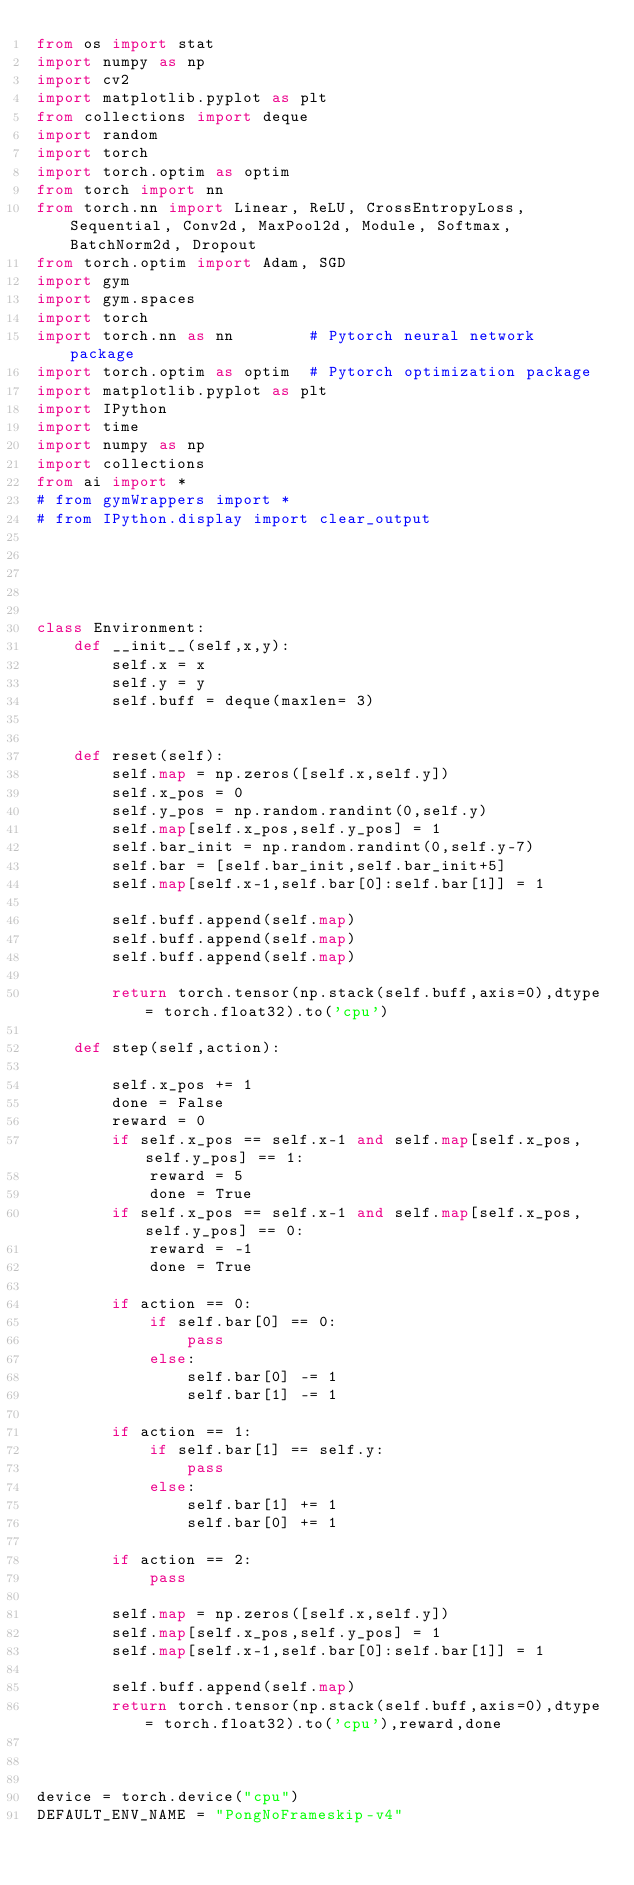Convert code to text. <code><loc_0><loc_0><loc_500><loc_500><_Python_>from os import stat
import numpy as np
import cv2
import matplotlib.pyplot as plt
from collections import deque
import random
import torch
import torch.optim as optim 
from torch import nn
from torch.nn import Linear, ReLU, CrossEntropyLoss, Sequential, Conv2d, MaxPool2d, Module, Softmax, BatchNorm2d, Dropout
from torch.optim import Adam, SGD
import gym
import gym.spaces
import torch
import torch.nn as nn        # Pytorch neural network package
import torch.optim as optim  # Pytorch optimization package
import matplotlib.pyplot as plt
import IPython
import time
import numpy as np
import collections
from ai import *
# from gymWrappers import *
# from IPython.display import clear_output





class Environment:
    def __init__(self,x,y):
        self.x = x
        self.y = y
        self.buff = deque(maxlen= 3)

        
    def reset(self):
        self.map = np.zeros([self.x,self.y])
        self.x_pos = 0
        self.y_pos = np.random.randint(0,self.y)
        self.map[self.x_pos,self.y_pos] = 1
        self.bar_init = np.random.randint(0,self.y-7)
        self.bar = [self.bar_init,self.bar_init+5]
        self.map[self.x-1,self.bar[0]:self.bar[1]] = 1

        self.buff.append(self.map)
        self.buff.append(self.map)
        self.buff.append(self.map)

        return torch.tensor(np.stack(self.buff,axis=0),dtype= torch.float32).to('cpu')
    
    def step(self,action):
        
        self.x_pos += 1
        done = False
        reward = 0
        if self.x_pos == self.x-1 and self.map[self.x_pos,self.y_pos] == 1:
            reward = 5
            done = True
        if self.x_pos == self.x-1 and self.map[self.x_pos,self.y_pos] == 0:
            reward = -1
            done = True
            
        if action == 0:
            if self.bar[0] == 0:
                pass
            else:
                self.bar[0] -= 1
                self.bar[1] -= 1
                
        if action == 1:
            if self.bar[1] == self.y:
                pass
            else:
                self.bar[1] += 1
                self.bar[0] += 1
                
        if action == 2:
            pass
                
        self.map = np.zeros([self.x,self.y])
        self.map[self.x_pos,self.y_pos] = 1
        self.map[self.x-1,self.bar[0]:self.bar[1]] = 1
        
        self.buff.append(self.map)
        return torch.tensor(np.stack(self.buff,axis=0),dtype= torch.float32).to('cpu'),reward,done
        
        
        
device = torch.device("cpu")
DEFAULT_ENV_NAME = "PongNoFrameskip-v4" </code> 